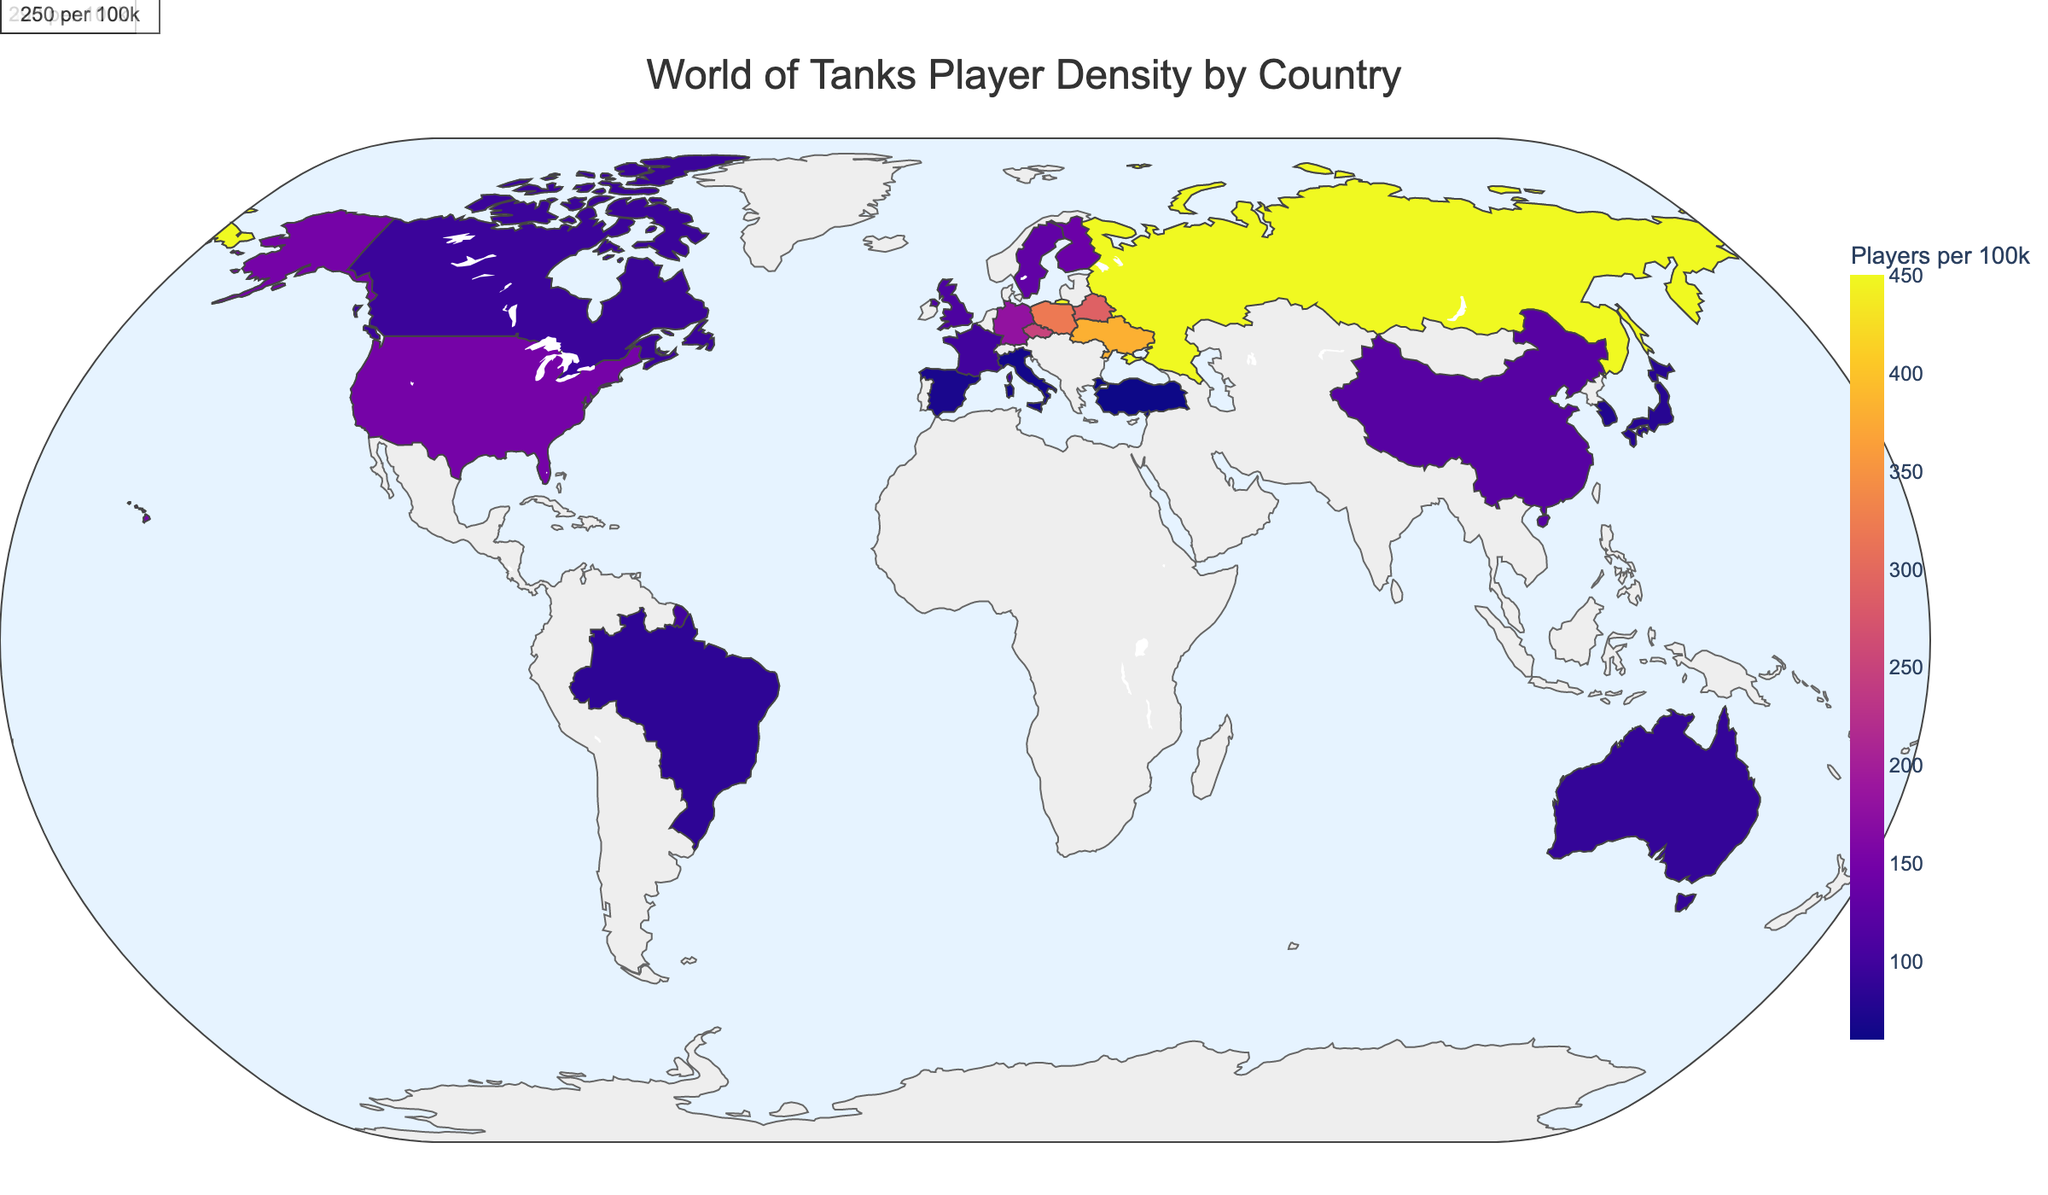What is the title of the plot? The title of the plot is typically at the top, and it describes the overall topic of the figure.
Answer: World of Tanks Player Density by Country Which country has the highest player density per 100k population? The highest player density per 100k population can be identified by looking at the country with the darkest color in the color scale. In this plot, it is Russia.
Answer: Russia How many total players are in the United States? Hover over the United States on the map, and the hover data will display the total number of players in that country.
Answer: 495,000 Name two countries with player density between 100 and 150 per 100k population. By looking at the color shades and hovering over countries, you can identify that Sweden and Finland fall within the 100-150 players per 100k range.
Answer: Sweden and Finland How does the player density of China compare to that of Japan? By comparing the color shades and values shown on hover, China has a player density of 120 per 100k population while Japan has a player density of 80 per 100k population. Thus, China's player density is higher.
Answer: China has a higher player density than Japan Which country has the fifth-highest player density per 100k population? Notice the annotations on the plot for the top 5 countries. The fifth annotation lists the Czech Republic.
Answer: Czech Republic What is the total number of players in France? Hover over France on the plot to view the hover data, which includes the total number of players.
Answer: 67,000 Calculate the average player density per 100k for Russia, Ukraine, and Poland. Add the player densities (450 for Russia, 380 for Ukraine, and 320 for Poland) and divide by 3. This gives (450 + 380 + 320) / 3 = 1150 / 3 ≈ 383.33.
Answer: 383.33 Which country between Brazil and Turkey has a lower player density per 100k population? Compare the player density values displayed on hover for both countries. Brazil has 85 while Turkey has 60 players per 100k population, so Turkey has a lower player density.
Answer: Turkey Identify the country with the smallest total number of players. By hovering over each country and checking the total number of players, you find that Finland has the smallest number with 7,700 total players.
Answer: Finland 